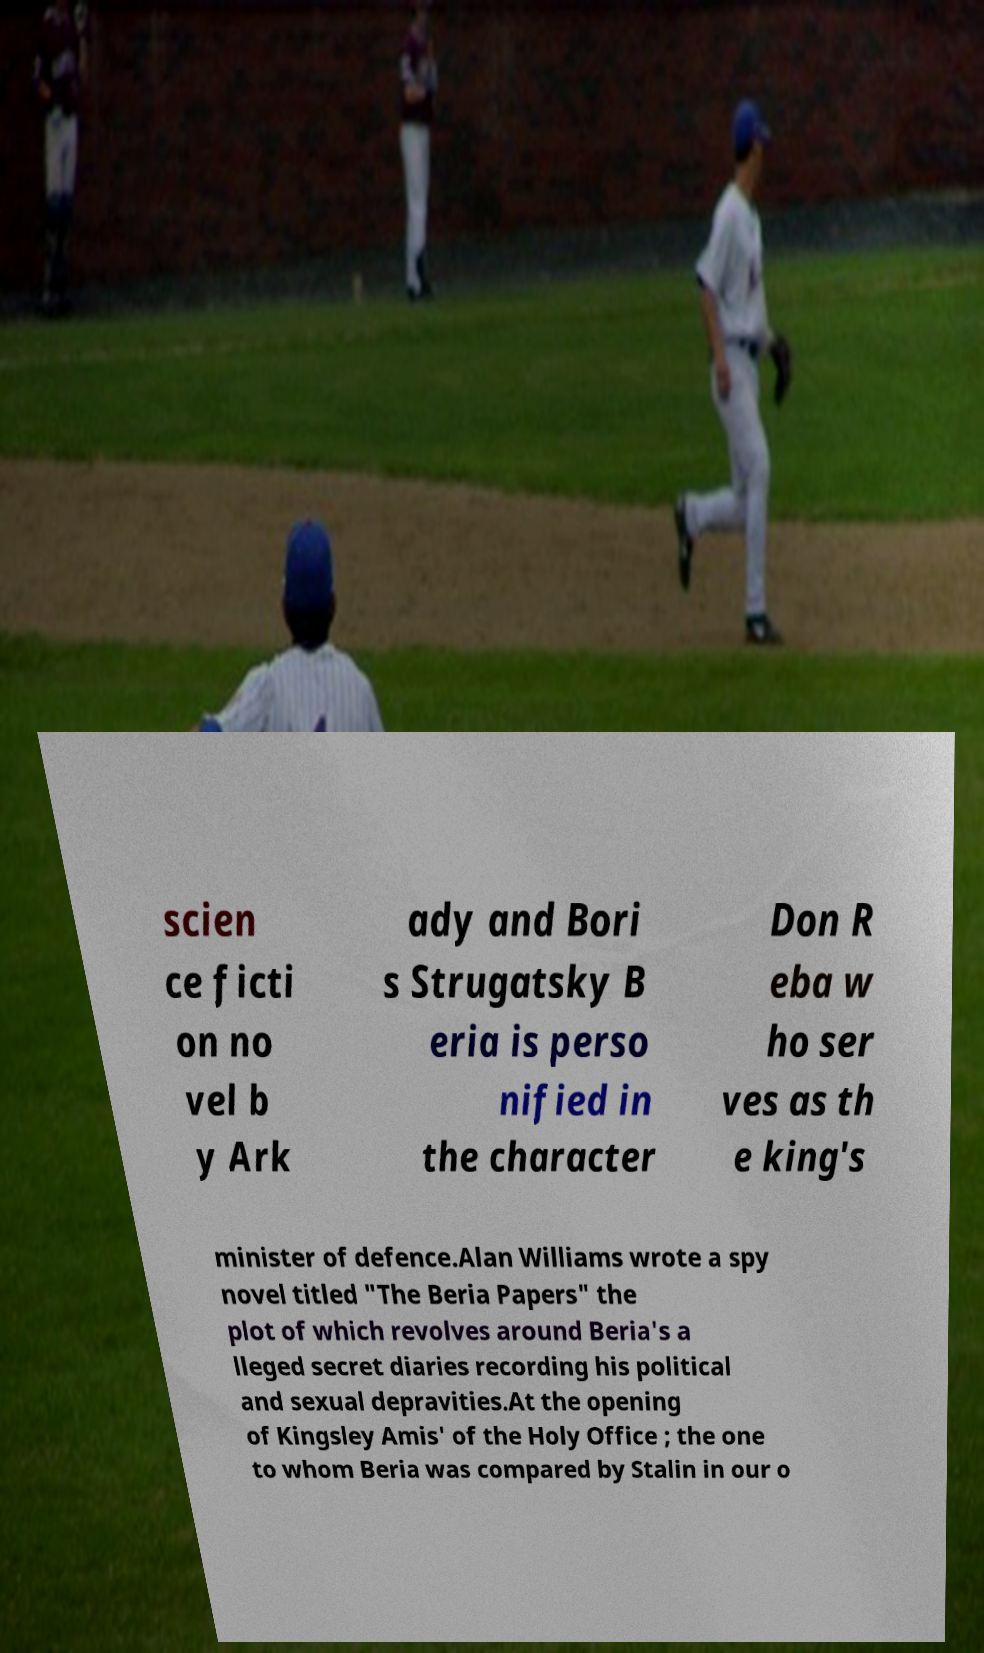What messages or text are displayed in this image? I need them in a readable, typed format. scien ce ficti on no vel b y Ark ady and Bori s Strugatsky B eria is perso nified in the character Don R eba w ho ser ves as th e king's minister of defence.Alan Williams wrote a spy novel titled "The Beria Papers" the plot of which revolves around Beria's a lleged secret diaries recording his political and sexual depravities.At the opening of Kingsley Amis' of the Holy Office ; the one to whom Beria was compared by Stalin in our o 